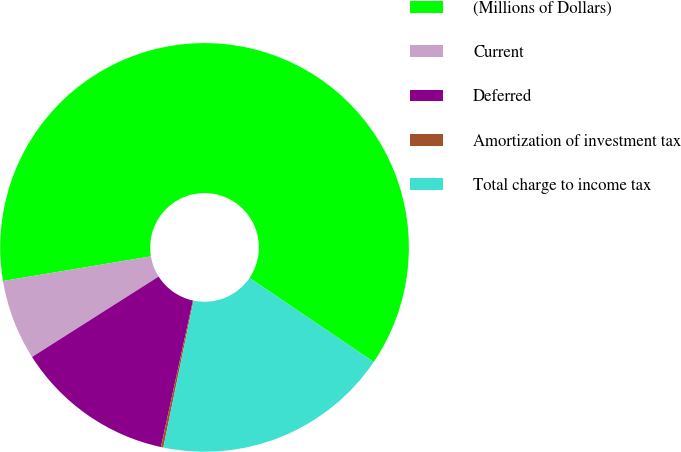<chart> <loc_0><loc_0><loc_500><loc_500><pie_chart><fcel>(Millions of Dollars)<fcel>Current<fcel>Deferred<fcel>Amortization of investment tax<fcel>Total charge to income tax<nl><fcel>62.11%<fcel>6.38%<fcel>12.57%<fcel>0.19%<fcel>18.76%<nl></chart> 